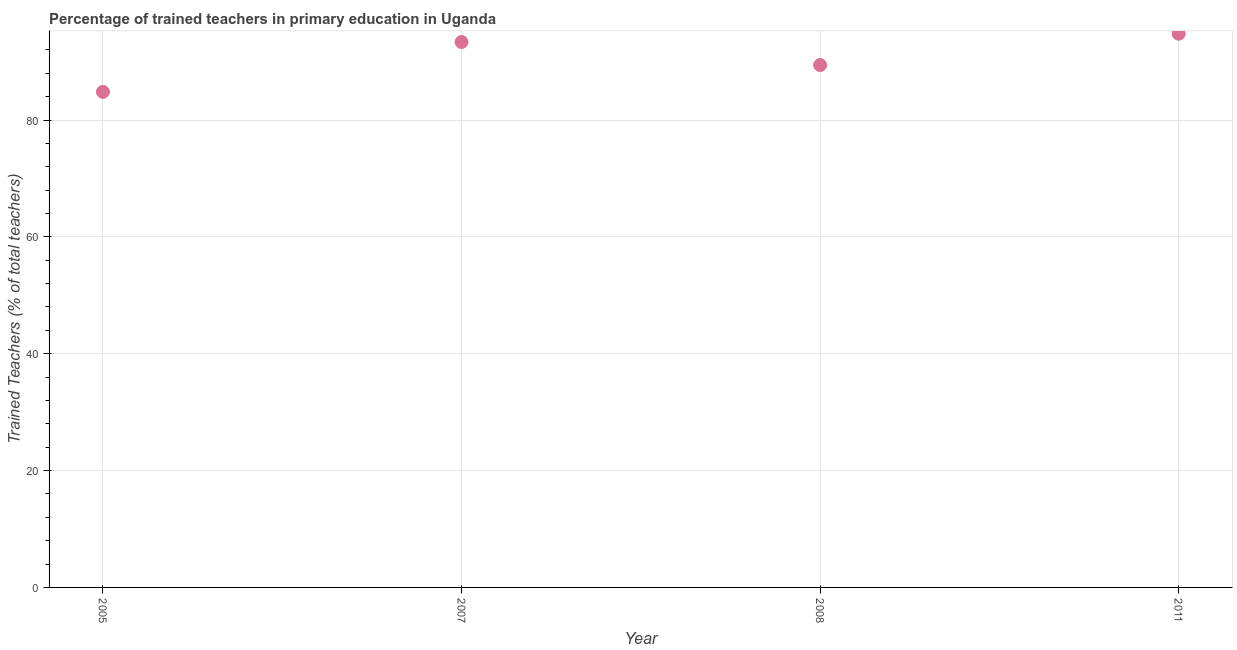What is the percentage of trained teachers in 2011?
Make the answer very short. 94.77. Across all years, what is the maximum percentage of trained teachers?
Provide a succinct answer. 94.77. Across all years, what is the minimum percentage of trained teachers?
Keep it short and to the point. 84.82. In which year was the percentage of trained teachers maximum?
Provide a succinct answer. 2011. In which year was the percentage of trained teachers minimum?
Offer a terse response. 2005. What is the sum of the percentage of trained teachers?
Your answer should be compact. 362.37. What is the difference between the percentage of trained teachers in 2005 and 2011?
Give a very brief answer. -9.95. What is the average percentage of trained teachers per year?
Offer a very short reply. 90.59. What is the median percentage of trained teachers?
Your answer should be very brief. 91.39. What is the ratio of the percentage of trained teachers in 2007 to that in 2008?
Provide a succinct answer. 1.04. Is the difference between the percentage of trained teachers in 2005 and 2007 greater than the difference between any two years?
Provide a succinct answer. No. What is the difference between the highest and the second highest percentage of trained teachers?
Offer a terse response. 1.41. Is the sum of the percentage of trained teachers in 2005 and 2008 greater than the maximum percentage of trained teachers across all years?
Provide a short and direct response. Yes. What is the difference between the highest and the lowest percentage of trained teachers?
Offer a terse response. 9.95. In how many years, is the percentage of trained teachers greater than the average percentage of trained teachers taken over all years?
Your answer should be very brief. 2. Does the percentage of trained teachers monotonically increase over the years?
Your answer should be compact. No. How many dotlines are there?
Provide a succinct answer. 1. How many years are there in the graph?
Your answer should be compact. 4. Are the values on the major ticks of Y-axis written in scientific E-notation?
Offer a very short reply. No. Does the graph contain any zero values?
Make the answer very short. No. What is the title of the graph?
Your response must be concise. Percentage of trained teachers in primary education in Uganda. What is the label or title of the Y-axis?
Provide a succinct answer. Trained Teachers (% of total teachers). What is the Trained Teachers (% of total teachers) in 2005?
Provide a short and direct response. 84.82. What is the Trained Teachers (% of total teachers) in 2007?
Offer a very short reply. 93.36. What is the Trained Teachers (% of total teachers) in 2008?
Your response must be concise. 89.42. What is the Trained Teachers (% of total teachers) in 2011?
Keep it short and to the point. 94.77. What is the difference between the Trained Teachers (% of total teachers) in 2005 and 2007?
Provide a short and direct response. -8.54. What is the difference between the Trained Teachers (% of total teachers) in 2005 and 2008?
Your answer should be compact. -4.6. What is the difference between the Trained Teachers (% of total teachers) in 2005 and 2011?
Your response must be concise. -9.95. What is the difference between the Trained Teachers (% of total teachers) in 2007 and 2008?
Your response must be concise. 3.94. What is the difference between the Trained Teachers (% of total teachers) in 2007 and 2011?
Provide a short and direct response. -1.41. What is the difference between the Trained Teachers (% of total teachers) in 2008 and 2011?
Make the answer very short. -5.36. What is the ratio of the Trained Teachers (% of total teachers) in 2005 to that in 2007?
Your response must be concise. 0.91. What is the ratio of the Trained Teachers (% of total teachers) in 2005 to that in 2008?
Give a very brief answer. 0.95. What is the ratio of the Trained Teachers (% of total teachers) in 2005 to that in 2011?
Your answer should be compact. 0.9. What is the ratio of the Trained Teachers (% of total teachers) in 2007 to that in 2008?
Your answer should be very brief. 1.04. What is the ratio of the Trained Teachers (% of total teachers) in 2008 to that in 2011?
Your answer should be very brief. 0.94. 